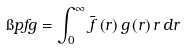Convert formula to latex. <formula><loc_0><loc_0><loc_500><loc_500>\i p { f } { g } = \int _ { 0 } ^ { \infty } \bar { f } \left ( r \right ) g \left ( r \right ) r \, d r</formula> 